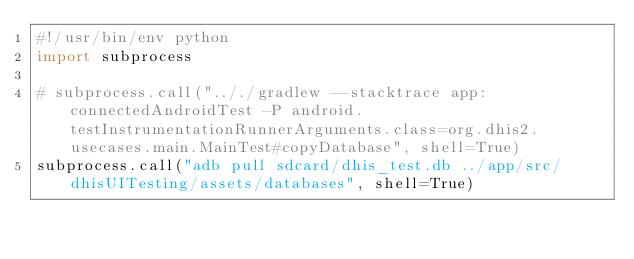<code> <loc_0><loc_0><loc_500><loc_500><_Python_>#!/usr/bin/env python
import subprocess

# subprocess.call(".././gradlew --stacktrace app:connectedAndroidTest -P android.testInstrumentationRunnerArguments.class=org.dhis2.usecases.main.MainTest#copyDatabase", shell=True)
subprocess.call("adb pull sdcard/dhis_test.db ../app/src/dhisUITesting/assets/databases", shell=True)
</code> 